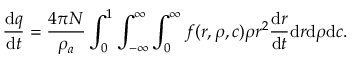<formula> <loc_0><loc_0><loc_500><loc_500>\frac { d q } { d t } = \frac { 4 \pi N } { \rho _ { a } } \int _ { 0 } ^ { 1 } \int _ { - \infty } ^ { \infty } \int _ { 0 } ^ { \infty } f ( r , \rho , c ) \rho r ^ { 2 } \frac { d r } { d t } d r d \rho d c .</formula> 